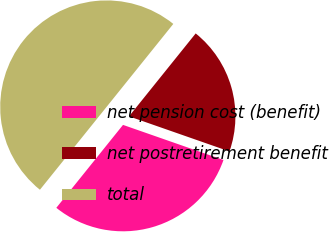<chart> <loc_0><loc_0><loc_500><loc_500><pie_chart><fcel>net pension cost (benefit)<fcel>net postretirement benefit<fcel>total<nl><fcel>30.43%<fcel>19.57%<fcel>50.0%<nl></chart> 